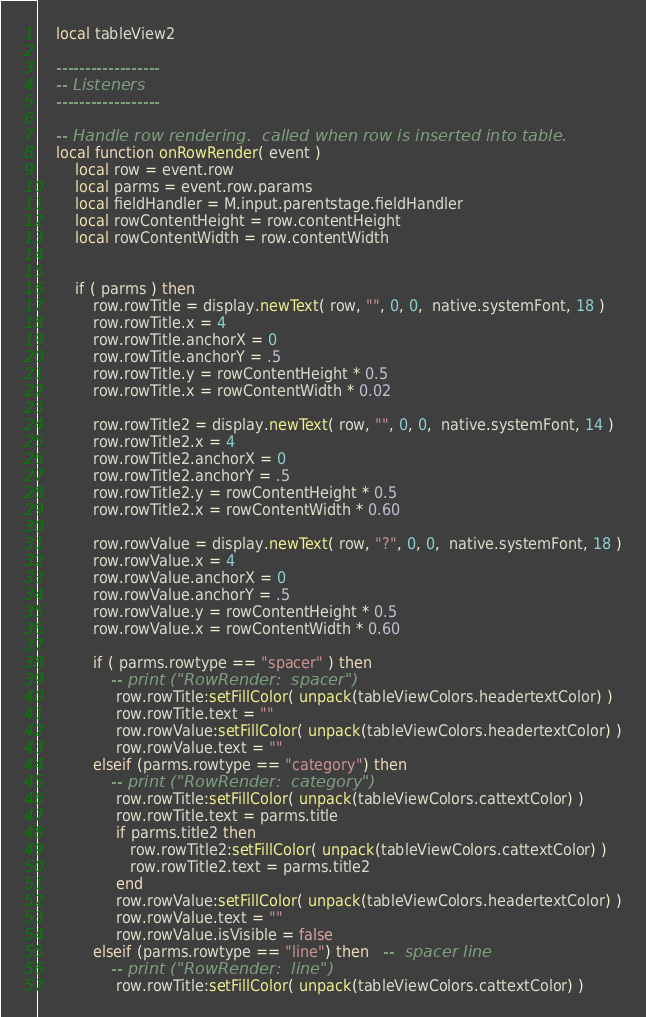Convert code to text. <code><loc_0><loc_0><loc_500><loc_500><_Lua_>	local tableView2
	
	------------------
	-- Listeners
	------------------
	
	-- Handle row rendering.  called when row is inserted into table.
	local function onRowRender( event )
		local row = event.row
		local parms = event.row.params
        local fieldHandler = M.input.parentstage.fieldHandler
		local rowContentHeight = row.contentHeight
		local rowContentWidth = row.contentWidth
		
		
		if ( parms ) then 
            row.rowTitle = display.newText( row, "", 0, 0,  native.systemFont, 18 )
            row.rowTitle.x = 4
            row.rowTitle.anchorX = 0
            row.rowTitle.anchorY = .5
            row.rowTitle.y = rowContentHeight * 0.5
            row.rowTitle.x = rowContentWidth * 0.02
            
            row.rowTitle2 = display.newText( row, "", 0, 0,  native.systemFont, 14 )
            row.rowTitle2.x = 4
            row.rowTitle2.anchorX = 0
            row.rowTitle2.anchorY = .5
            row.rowTitle2.y = rowContentHeight * 0.5
            row.rowTitle2.x = rowContentWidth * 0.60
            
            row.rowValue = display.newText( row, "?", 0, 0,  native.systemFont, 18 )
            row.rowValue.x = 4
            row.rowValue.anchorX = 0
            row.rowValue.anchorY = .5
            row.rowValue.y = rowContentHeight * 0.5
            row.rowValue.x = rowContentWidth * 0.60
            
            if ( parms.rowtype == "spacer" ) then
                -- print ("RowRender:  spacer")
                 row.rowTitle:setFillColor( unpack(tableViewColors.headertextColor) )
                 row.rowTitle.text = ""
                 row.rowValue:setFillColor( unpack(tableViewColors.headertextColor) )
                 row.rowValue.text = ""
            elseif (parms.rowtype == "category") then
                -- print ("RowRender:  category")
                 row.rowTitle:setFillColor( unpack(tableViewColors.cattextColor) )
                 row.rowTitle.text = parms.title
                 if parms.title2 then 
                    row.rowTitle2:setFillColor( unpack(tableViewColors.cattextColor) )
                    row.rowTitle2.text = parms.title2
                 end    
                 row.rowValue:setFillColor( unpack(tableViewColors.headertextColor) )
                 row.rowValue.text = ""
                 row.rowValue.isVisible = false
            elseif (parms.rowtype == "line") then   --  spacer line
                -- print ("RowRender:  line")
                 row.rowTitle:setFillColor( unpack(tableViewColors.cattextColor) )</code> 